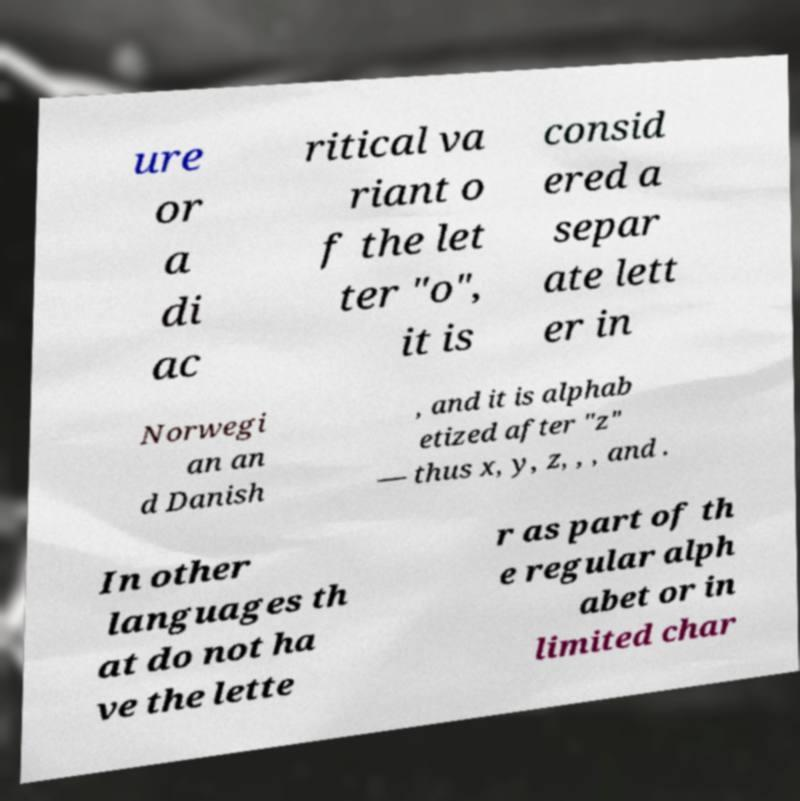There's text embedded in this image that I need extracted. Can you transcribe it verbatim? ure or a di ac ritical va riant o f the let ter "o", it is consid ered a separ ate lett er in Norwegi an an d Danish , and it is alphab etized after "z" — thus x, y, z, , , and . In other languages th at do not ha ve the lette r as part of th e regular alph abet or in limited char 